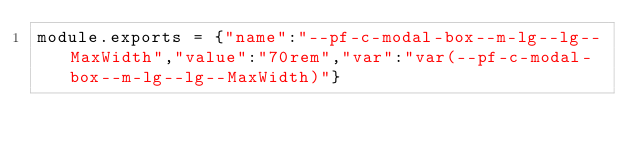Convert code to text. <code><loc_0><loc_0><loc_500><loc_500><_JavaScript_>module.exports = {"name":"--pf-c-modal-box--m-lg--lg--MaxWidth","value":"70rem","var":"var(--pf-c-modal-box--m-lg--lg--MaxWidth)"}
</code> 